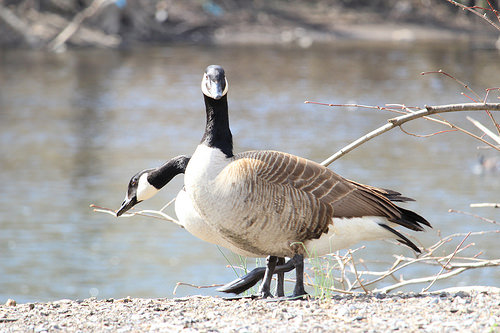<image>
Is the goose behind the goose? Yes. From this viewpoint, the goose is positioned behind the goose, with the goose partially or fully occluding the goose. Where is the water in relation to the bird? Is it behind the bird? Yes. From this viewpoint, the water is positioned behind the bird, with the bird partially or fully occluding the water. 